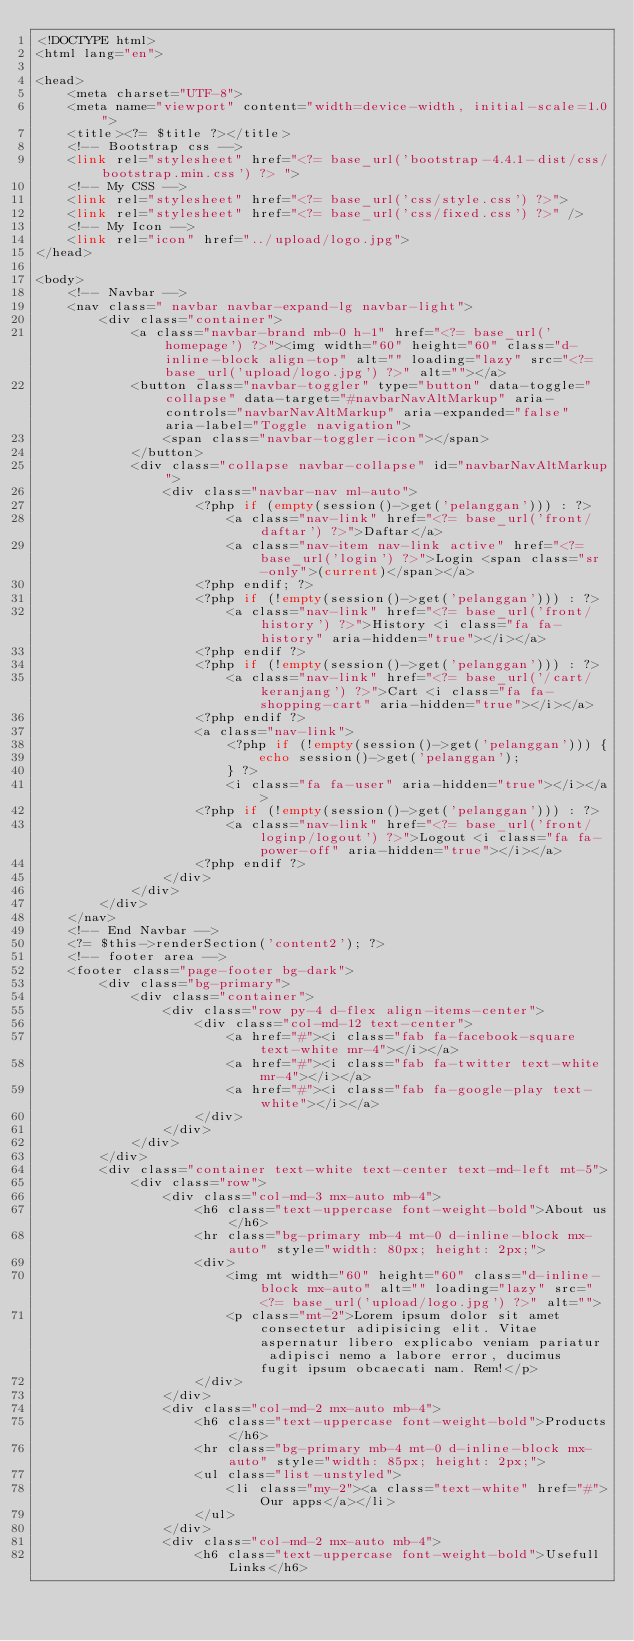<code> <loc_0><loc_0><loc_500><loc_500><_PHP_><!DOCTYPE html>
<html lang="en">

<head>
    <meta charset="UTF-8">
    <meta name="viewport" content="width=device-width, initial-scale=1.0">
    <title><?= $title ?></title>
    <!-- Bootstrap css -->
    <link rel="stylesheet" href="<?= base_url('bootstrap-4.4.1-dist/css/bootstrap.min.css') ?> ">
    <!-- My CSS -->
    <link rel="stylesheet" href="<?= base_url('css/style.css') ?>">
    <link rel="stylesheet" href="<?= base_url('css/fixed.css') ?>" />
    <!-- My Icon -->
    <link rel="icon" href="../upload/logo.jpg">
</head>

<body>
    <!-- Navbar -->
    <nav class=" navbar navbar-expand-lg navbar-light">
        <div class="container">
            <a class="navbar-brand mb-0 h-1" href="<?= base_url('homepage') ?>"><img width="60" height="60" class="d-inline-block align-top" alt="" loading="lazy" src="<?= base_url('upload/logo.jpg') ?>" alt=""></a>
            <button class="navbar-toggler" type="button" data-toggle="collapse" data-target="#navbarNavAltMarkup" aria-controls="navbarNavAltMarkup" aria-expanded="false" aria-label="Toggle navigation">
                <span class="navbar-toggler-icon"></span>
            </button>
            <div class="collapse navbar-collapse" id="navbarNavAltMarkup">
                <div class="navbar-nav ml-auto">
                    <?php if (empty(session()->get('pelanggan'))) : ?>
                        <a class="nav-link" href="<?= base_url('front/daftar') ?>">Daftar</a>
                        <a class="nav-item nav-link active" href="<?= base_url('login') ?>">Login <span class="sr-only">(current)</span></a>
                    <?php endif; ?>
                    <?php if (!empty(session()->get('pelanggan'))) : ?>
                        <a class="nav-link" href="<?= base_url('front/history') ?>">History <i class="fa fa-history" aria-hidden="true"></i></a>
                    <?php endif ?>
                    <?php if (!empty(session()->get('pelanggan'))) : ?>
                        <a class="nav-link" href="<?= base_url('/cart/keranjang') ?>">Cart <i class="fa fa-shopping-cart" aria-hidden="true"></i></a>
                    <?php endif ?>
                    <a class="nav-link">
                        <?php if (!empty(session()->get('pelanggan'))) {
                            echo session()->get('pelanggan');
                        } ?>
                        <i class="fa fa-user" aria-hidden="true"></i></a>
                    <?php if (!empty(session()->get('pelanggan'))) : ?>
                        <a class="nav-link" href="<?= base_url('front/loginp/logout') ?>">Logout <i class="fa fa-power-off" aria-hidden="true"></i></a>
                    <?php endif ?>
                </div>
            </div>
        </div>
    </nav>
    <!-- End Navbar -->
    <?= $this->renderSection('content2'); ?>
    <!-- footer area -->
    <footer class="page-footer bg-dark">
        <div class="bg-primary">
            <div class="container">
                <div class="row py-4 d-flex align-items-center">
                    <div class="col-md-12 text-center">
                        <a href="#"><i class="fab fa-facebook-square text-white mr-4"></i></a>
                        <a href="#"><i class="fab fa-twitter text-white mr-4"></i></a>
                        <a href="#"><i class="fab fa-google-play text-white"></i></a>
                    </div>
                </div>
            </div>
        </div>
        <div class="container text-white text-center text-md-left mt-5">
            <div class="row">
                <div class="col-md-3 mx-auto mb-4">
                    <h6 class="text-uppercase font-weight-bold">About us</h6>
                    <hr class="bg-primary mb-4 mt-0 d-inline-block mx-auto" style="width: 80px; height: 2px;">
                    <div>
                        <img mt width="60" height="60" class="d-inline-block mx-auto" alt="" loading="lazy" src="<?= base_url('upload/logo.jpg') ?>" alt="">
                        <p class="mt-2">Lorem ipsum dolor sit amet consectetur adipisicing elit. Vitae aspernatur libero explicabo veniam pariatur adipisci nemo a labore error, ducimus fugit ipsum obcaecati nam. Rem!</p>
                    </div>
                </div>
                <div class="col-md-2 mx-auto mb-4">
                    <h6 class="text-uppercase font-weight-bold">Products</h6>
                    <hr class="bg-primary mb-4 mt-0 d-inline-block mx-auto" style="width: 85px; height: 2px;">
                    <ul class="list-unstyled">
                        <li class="my-2"><a class="text-white" href="#">Our apps</a></li>
                    </ul>
                </div>
                <div class="col-md-2 mx-auto mb-4">
                    <h6 class="text-uppercase font-weight-bold">Usefull Links</h6></code> 